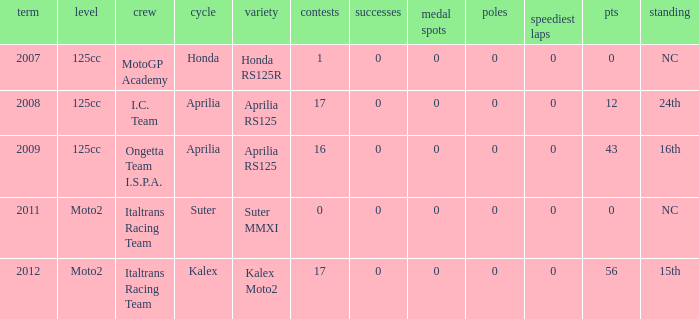How many fastest laps did I.C. Team have? 1.0. 